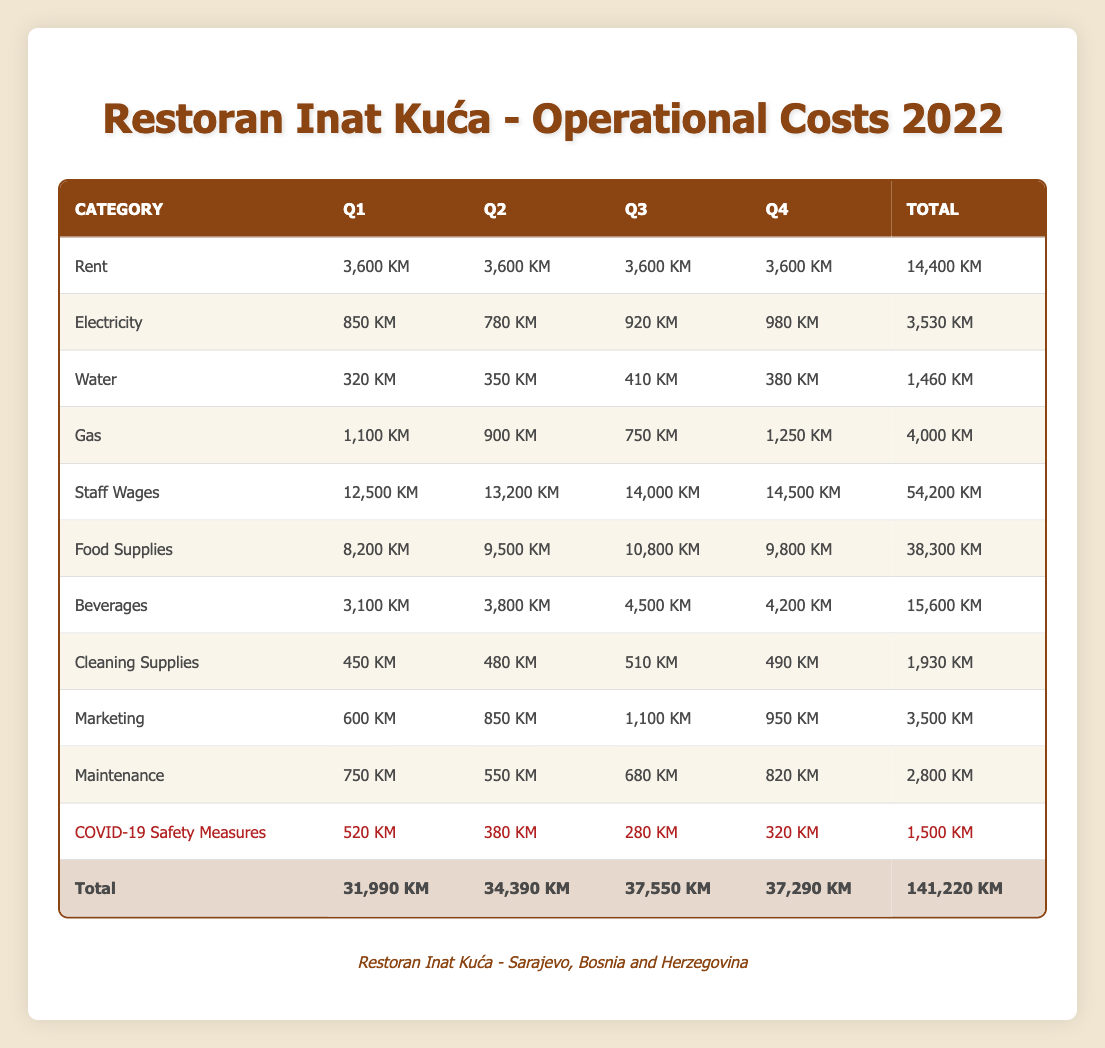What are the total staff wages for all quarters? To find the total staff wages, we need to sum the staff wages for all four quarters: 12,500 KM + 13,200 KM + 14,000 KM + 14,500 KM = 54,200 KM.
Answer: 54,200 KM Which quarter had the highest operational costs? The total operational costs for each quarter are as follows: Q1 - 31,990 KM, Q2 - 34,390 KM, Q3 - 37,550 KM, Q4 - 37,290 KM. The highest total is 37,550 KM in Q3.
Answer: Q3 How much did the restaurant spend on COVID-19 safety measures throughout the year? To find the total spent on COVID-19 safety measures, we sum the amounts for each quarter: 520 KM + 380 KM + 280 KM + 320 KM = 1,500 KM.
Answer: 1,500 KM Did the restaurant's spending on food supplies increase in the second quarter compared to the first? In Q1, the spending on food supplies was 8,200 KM, and in Q2 it was 9,500 KM. Since 9,500 KM is greater than 8,200 KM, the restaurant did increase its spending on food supplies in Q2.
Answer: Yes What is the average cost for utilities (electricity, water, and gas) in Q4? First, we need to calculate the total utility costs in Q4: 980 KM (electricity) + 380 KM (water) + 1,250 KM (gas) = 2,610 KM. Next, we find the average by dividing by the number of categories (3): 2,610 KM / 3 = 870 KM.
Answer: 870 KM How much did the restaurant spend on beverages in the third quarter? The table indicates that the restaurant spent 4,500 KM on beverages in Q3.
Answer: 4,500 KM Which utility had the lowest cost overall throughout the year? We need to identify the total costs for each utility: Electricity - 3,530 KM, Water - 1,460 KM, Gas - 4,000 KM. The lowest cost is 1,460 KM for water.
Answer: Water What is the total cost for marketing in 2022? To find the total marketing costs, we sum the amounts for all four quarters: 600 KM + 850 KM + 1,100 KM + 950 KM = 3,500 KM.
Answer: 3,500 KM 